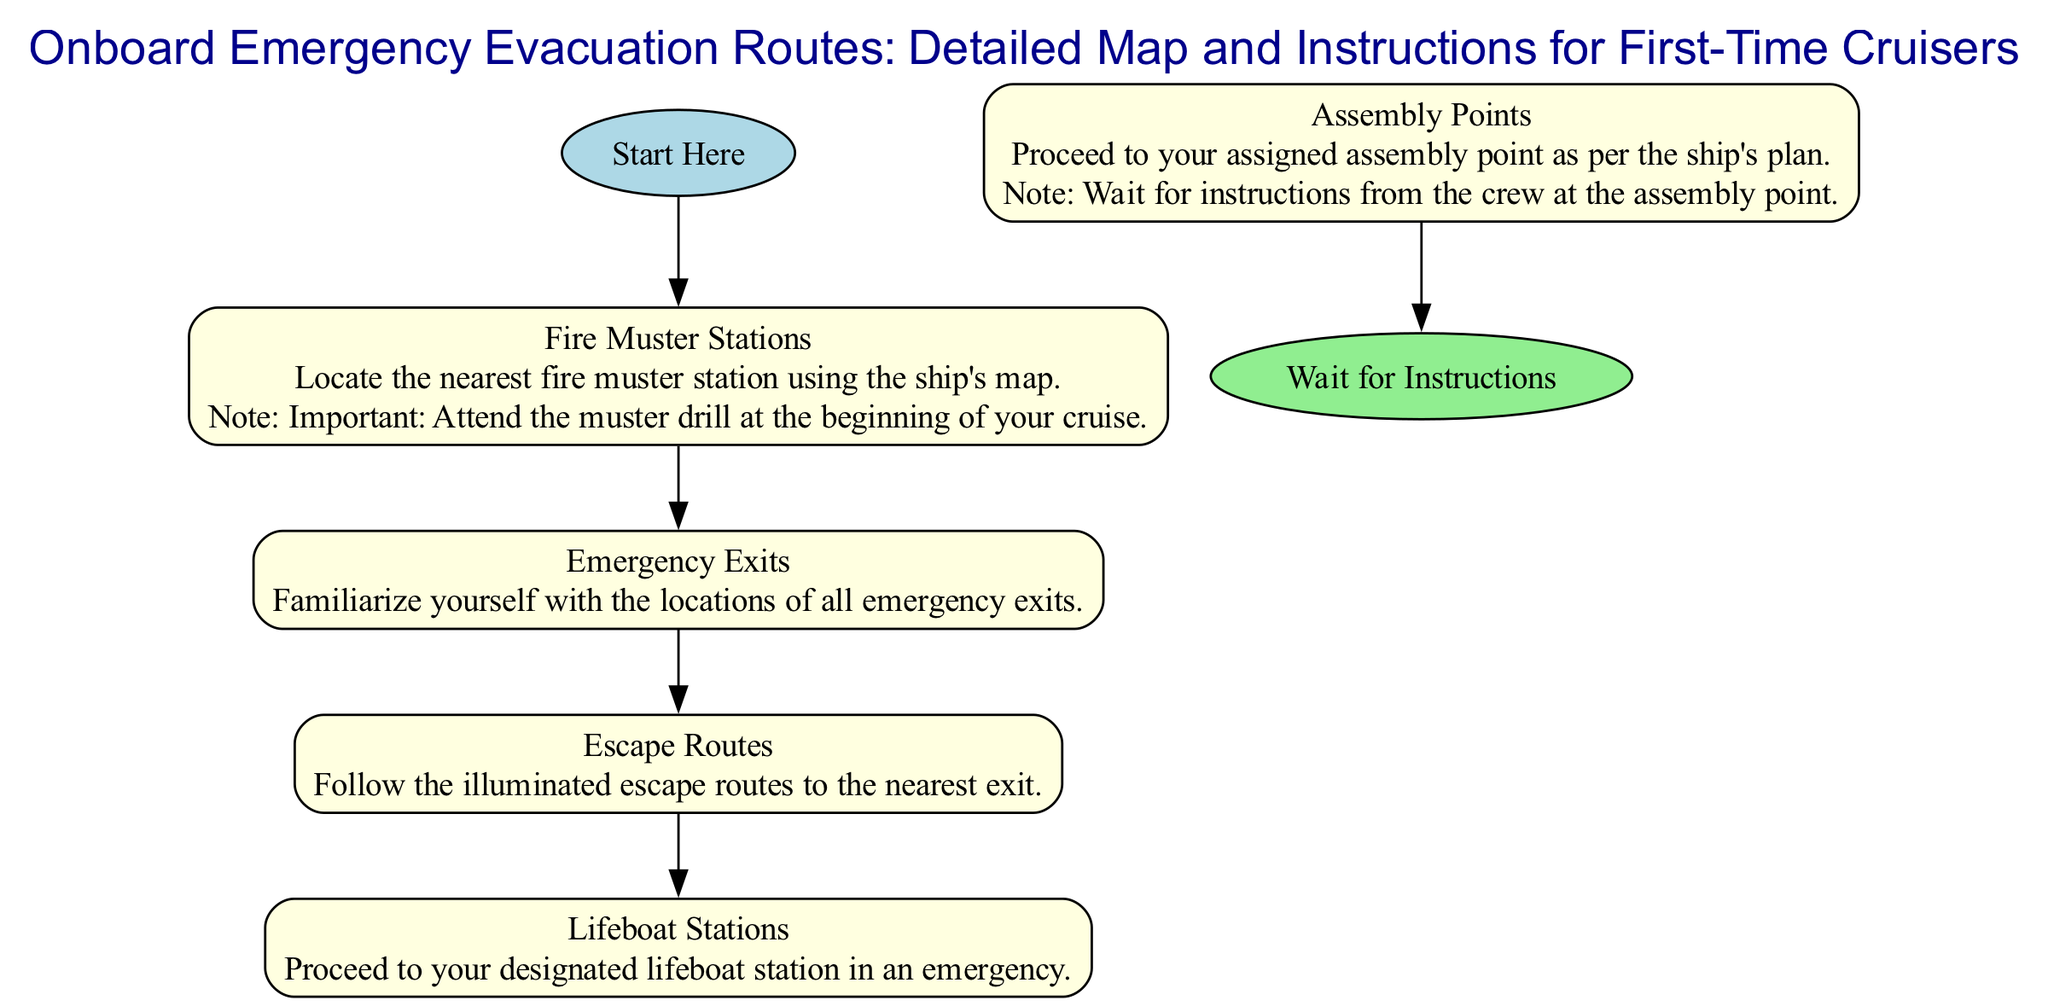What is the title of the diagram? The title is presented at the top of the diagram and clearly states the subject, which is "Onboard Emergency Evacuation Routes: Detailed Map and Instructions for First-Time Cruisers".
Answer: Onboard Emergency Evacuation Routes: Detailed Map and Instructions for First-Time Cruisers How many main sections are there in the diagram? The diagram contains five main sections: Fire Muster Stations, Emergency Exits, Escape Routes, Lifeboat Stations, and Assembly Points. Each of these is distinctly indicated within the diagram.
Answer: 5 What should you do at the Fire Muster Station? The text associated with the Fire Muster Station indicates that you should locate the nearest station using the ship's map and emphasizes the importance of attending the muster drill.
Answer: Locate nearest station and attend muster drill What shape represents the start of the evacuation route? The start of the evacuation route is represented as an ellipse in the diagram, which is filled with light blue color.
Answer: Ellipse Where do you wait for instructions at the end of the evacuation route? The diagram clearly indicates that you should "Wait for Instructions" at the end of the evacuation route, which is marked as an ellipse filled with light green color.
Answer: Wait for Instructions How do you identify the escape routes? Escape routes are to be followed using illuminated indicators, which are clearly defined in the diagram. The text states that you should "Follow the illuminated escape routes to the nearest exit".
Answer: Follow illuminated escape routes What is the note associated with Assembly Points? The note associated with Assembly Points instructs individuals to wait for instructions from the crew at the assembly point, highlighting the importance of crew communication during emergencies.
Answer: Wait for instructions from the crew at the assembly point In what order should you follow the sections according to the diagram? The order of the sections is: Fire Muster Stations → Emergency Exits → Escape Routes → Lifeboat Stations → Assembly Points. This sequence guides the flow of evacuation actions.
Answer: Fire Muster Stations, Emergency Exits, Escape Routes, Lifeboat Stations, Assembly Points What is the icon for Lifeboat Stations? The Lifeboat Station is represented by an icon that is mentioned in the section dedicated to it, although the specific visual is not described in text form, the existence of a lifeboat station icon lends clarity to its recognition.
Answer: Lifeboat Station Icon 